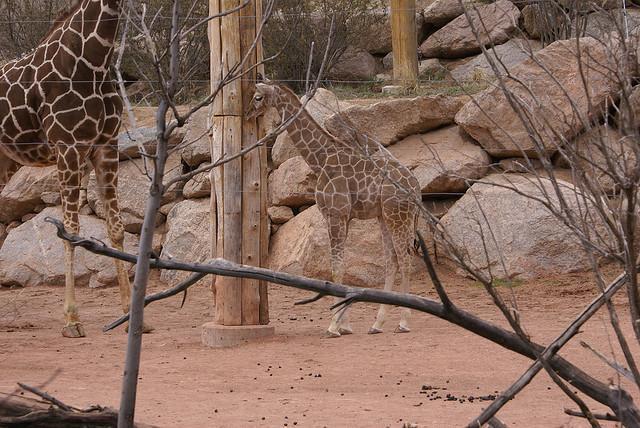How many animals are there?
Give a very brief answer. 2. How many giraffes?
Give a very brief answer. 2. How many giraffes are in the picture?
Give a very brief answer. 2. How many zebras are there?
Give a very brief answer. 0. How many legs does the giraffe have?
Give a very brief answer. 4. How many giraffes are in the photo?
Give a very brief answer. 2. 